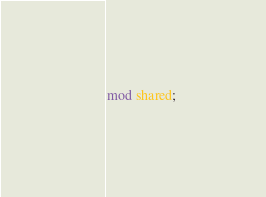<code> <loc_0><loc_0><loc_500><loc_500><_Rust_>mod shared;
</code> 